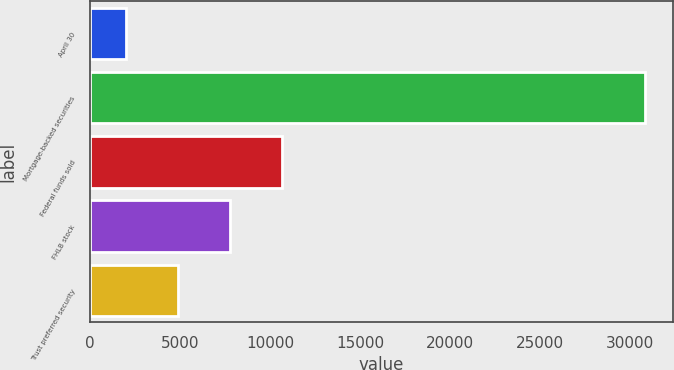<chart> <loc_0><loc_0><loc_500><loc_500><bar_chart><fcel>April 30<fcel>Mortgage-backed securities<fcel>Federal funds sold<fcel>FHLB stock<fcel>Trust preferred security<nl><fcel>2008<fcel>30809<fcel>10648.3<fcel>7768.2<fcel>4888.1<nl></chart> 